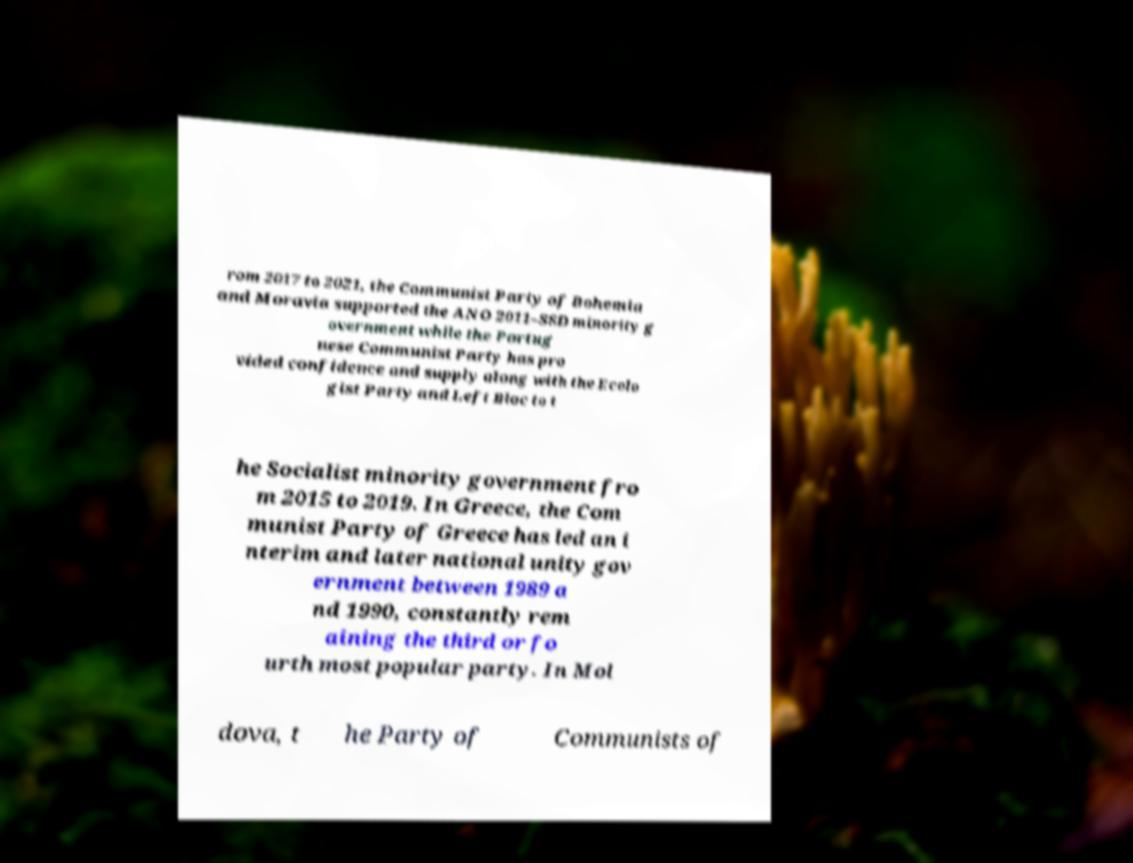Please read and relay the text visible in this image. What does it say? rom 2017 to 2021, the Communist Party of Bohemia and Moravia supported the ANO 2011–SSD minority g overnment while the Portug uese Communist Party has pro vided confidence and supply along with the Ecolo gist Party and Left Bloc to t he Socialist minority government fro m 2015 to 2019. In Greece, the Com munist Party of Greece has led an i nterim and later national unity gov ernment between 1989 a nd 1990, constantly rem aining the third or fo urth most popular party. In Mol dova, t he Party of Communists of 